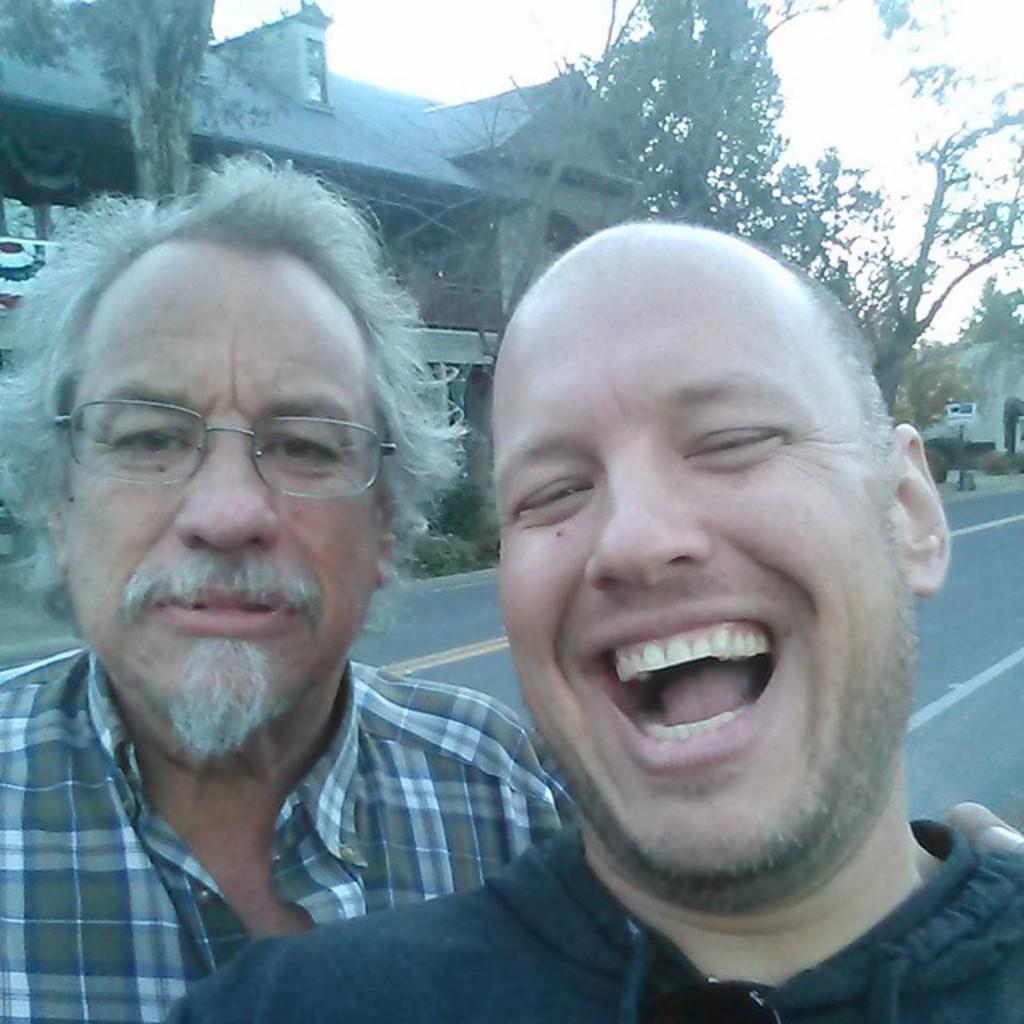Please provide a concise description of this image. In this image there are two men in the middle. The man on the right side is laughing by opening his mouth. Behind them there is a road. In the background there is a building. Beside the building there are trees. 